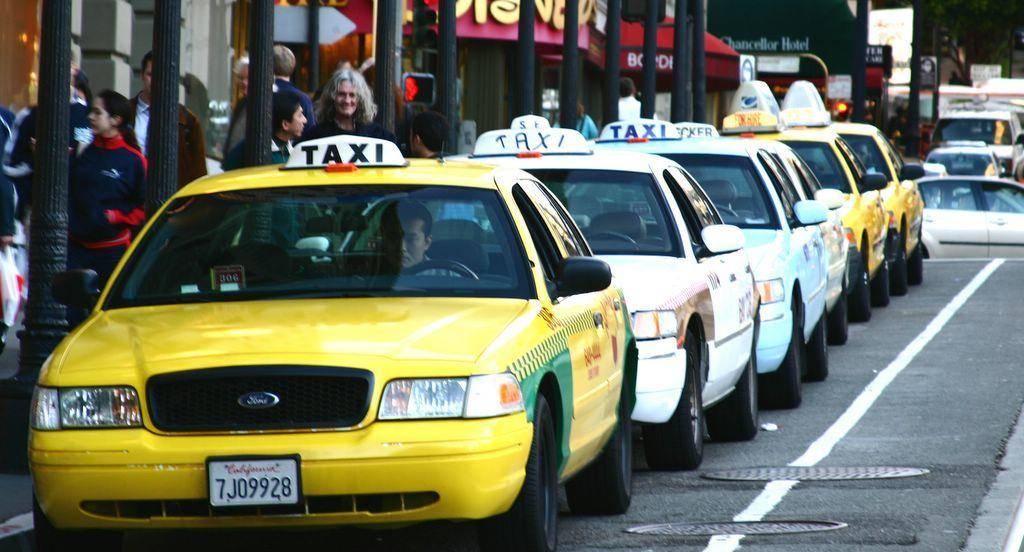Provide a one-sentence caption for the provided image. a group of taxis and one with a california license plate. 